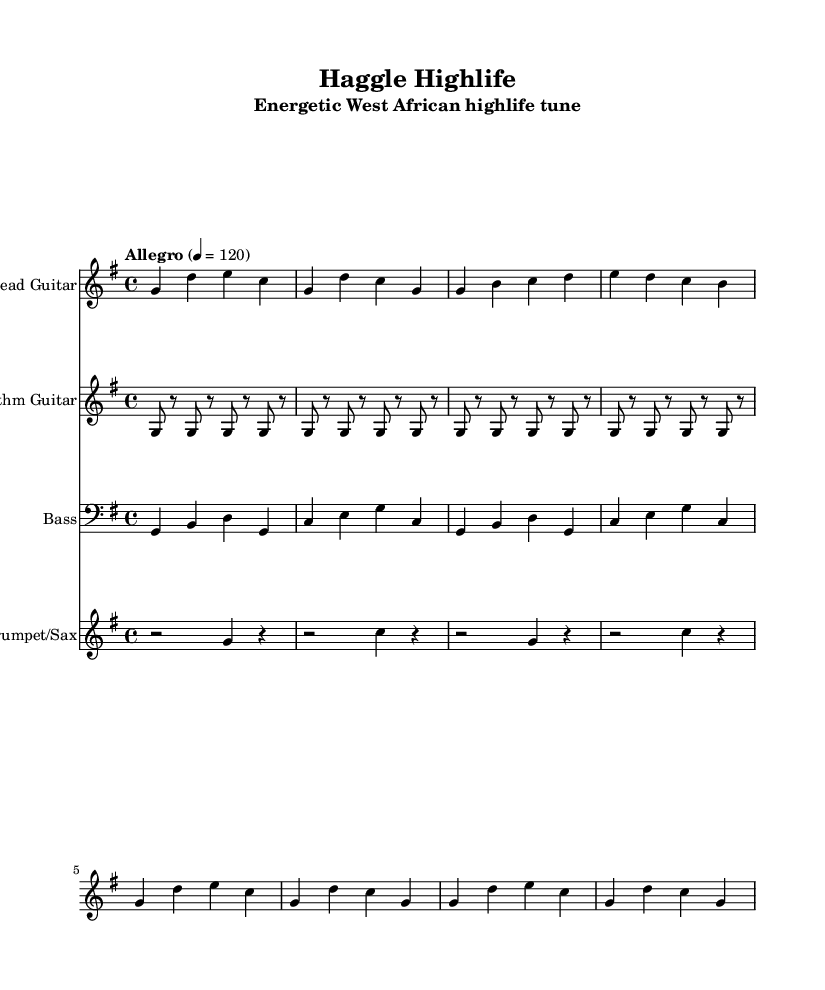What is the key signature of this music? The key signature is G major, which has one sharp (F#).
Answer: G major What is the time signature of this tune? The time signature is 4/4, indicating four beats per measure.
Answer: 4/4 What is the indicated tempo for the piece? The tempo is marked as "Allegro," with a specific metronome marking of 120 beats per minute.
Answer: Allegro How many bars are in the lead guitar intro? The lead guitar intro consists of 2 bars of music as indicated before the verse begins.
Answer: 2 What is the rhythm of the rhythm guitar? The rhythm guitar features a repeated pattern of eighth notes followed by rests, creating a lively rhythm typical of highlife music.
Answer: Simplified highlife rhythm Which instrument plays the 'horn stabs'? The trumpet/sax section is responsible for playing the horn stabs within the piece.
Answer: Trumpet/Sax What type of bass line is featured in this piece? The bass guitar utilizes a simplified walking bass pattern over the chords, creating a grounded and dynamic foundation for the music.
Answer: Simplified walking bass 